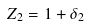<formula> <loc_0><loc_0><loc_500><loc_500>Z _ { 2 } = 1 + \delta _ { 2 }</formula> 